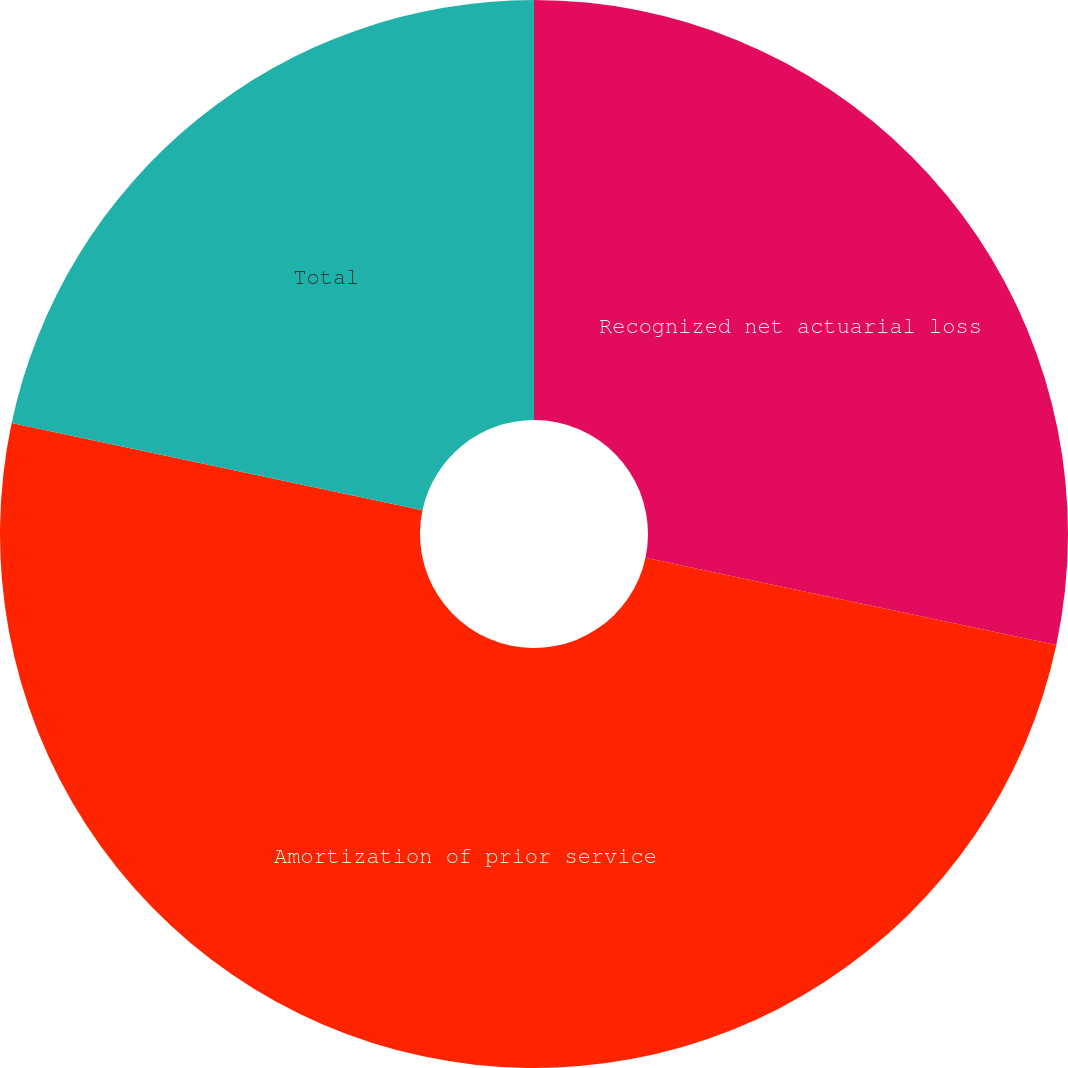Convert chart. <chart><loc_0><loc_0><loc_500><loc_500><pie_chart><fcel>Recognized net actuarial loss<fcel>Amortization of prior service<fcel>Total<nl><fcel>28.33%<fcel>50.0%<fcel>21.67%<nl></chart> 